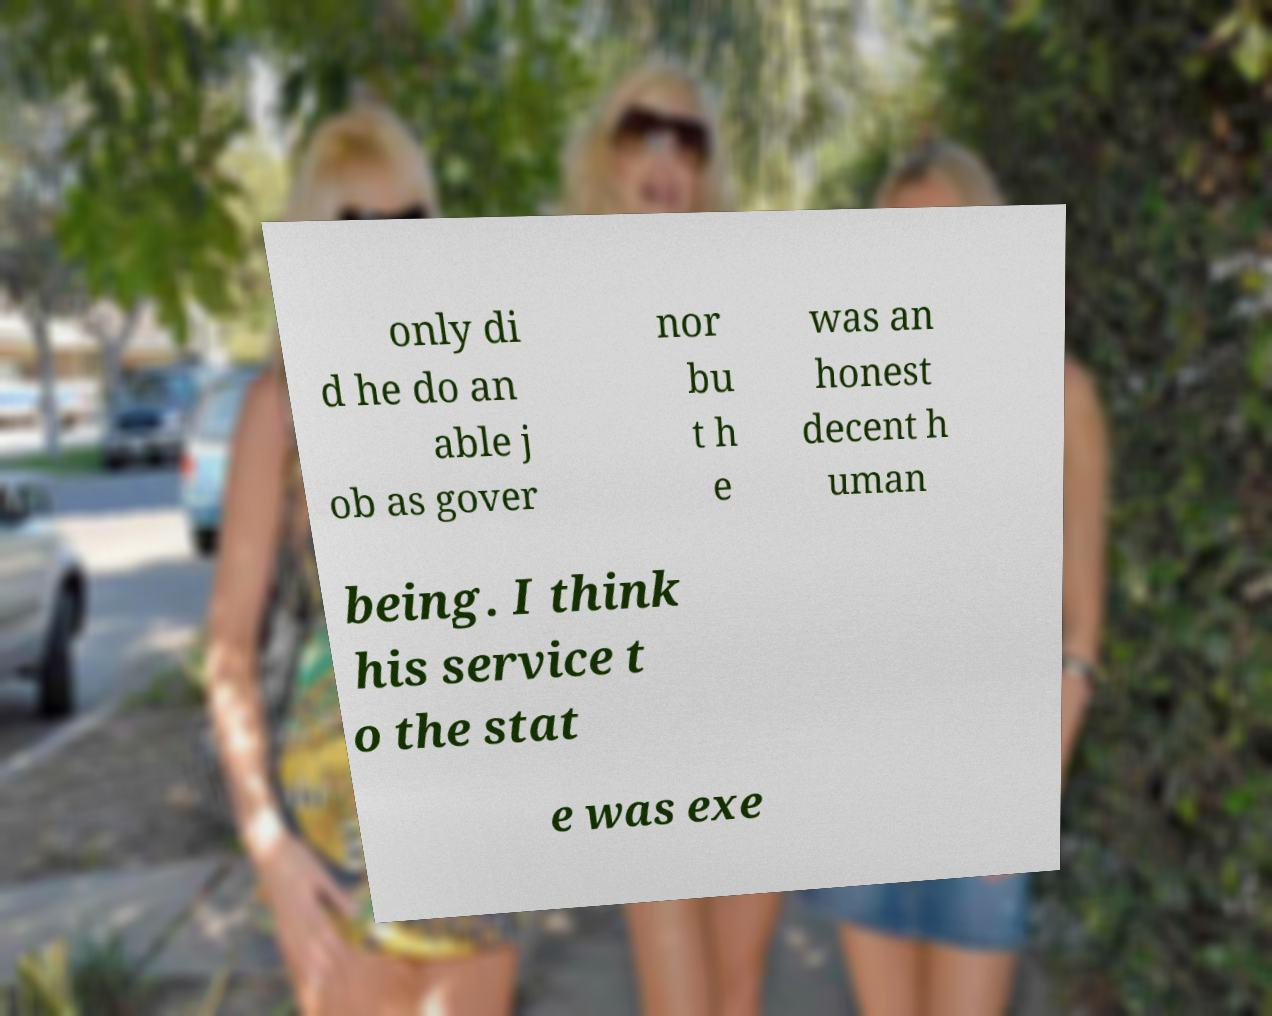Can you read and provide the text displayed in the image?This photo seems to have some interesting text. Can you extract and type it out for me? only di d he do an able j ob as gover nor bu t h e was an honest decent h uman being. I think his service t o the stat e was exe 